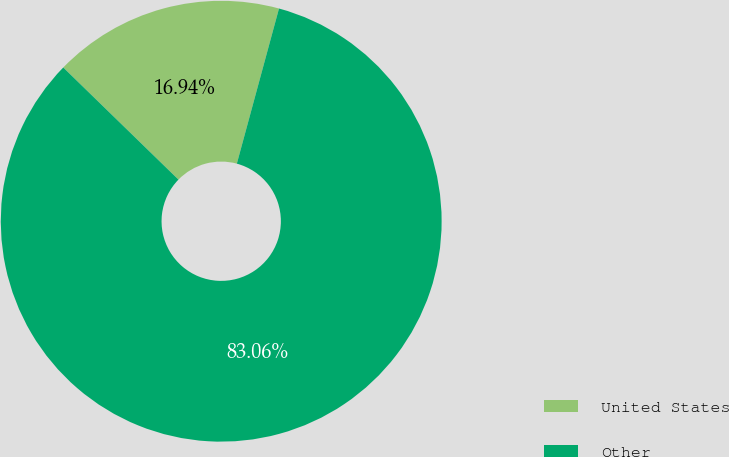Convert chart to OTSL. <chart><loc_0><loc_0><loc_500><loc_500><pie_chart><fcel>United States<fcel>Other<nl><fcel>16.94%<fcel>83.06%<nl></chart> 